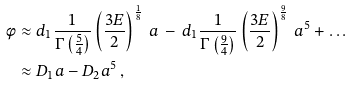<formula> <loc_0><loc_0><loc_500><loc_500>\phi & \approx d _ { 1 } \frac { 1 } { \Gamma \left ( \frac { 5 } { 4 } \right ) } \left ( \frac { 3 E } { 2 } \right ) ^ { \frac { 1 } { 8 } } \, a \, - \, d _ { 1 } \frac { 1 } { \Gamma \left ( \frac { 9 } { 4 } \right ) } \left ( \frac { 3 E } { 2 } \right ) ^ { \frac { 9 } { 8 } } \, a ^ { 5 } + \dots \\ & \approx D _ { 1 } a - D _ { 2 } a ^ { 5 } \, ,</formula> 